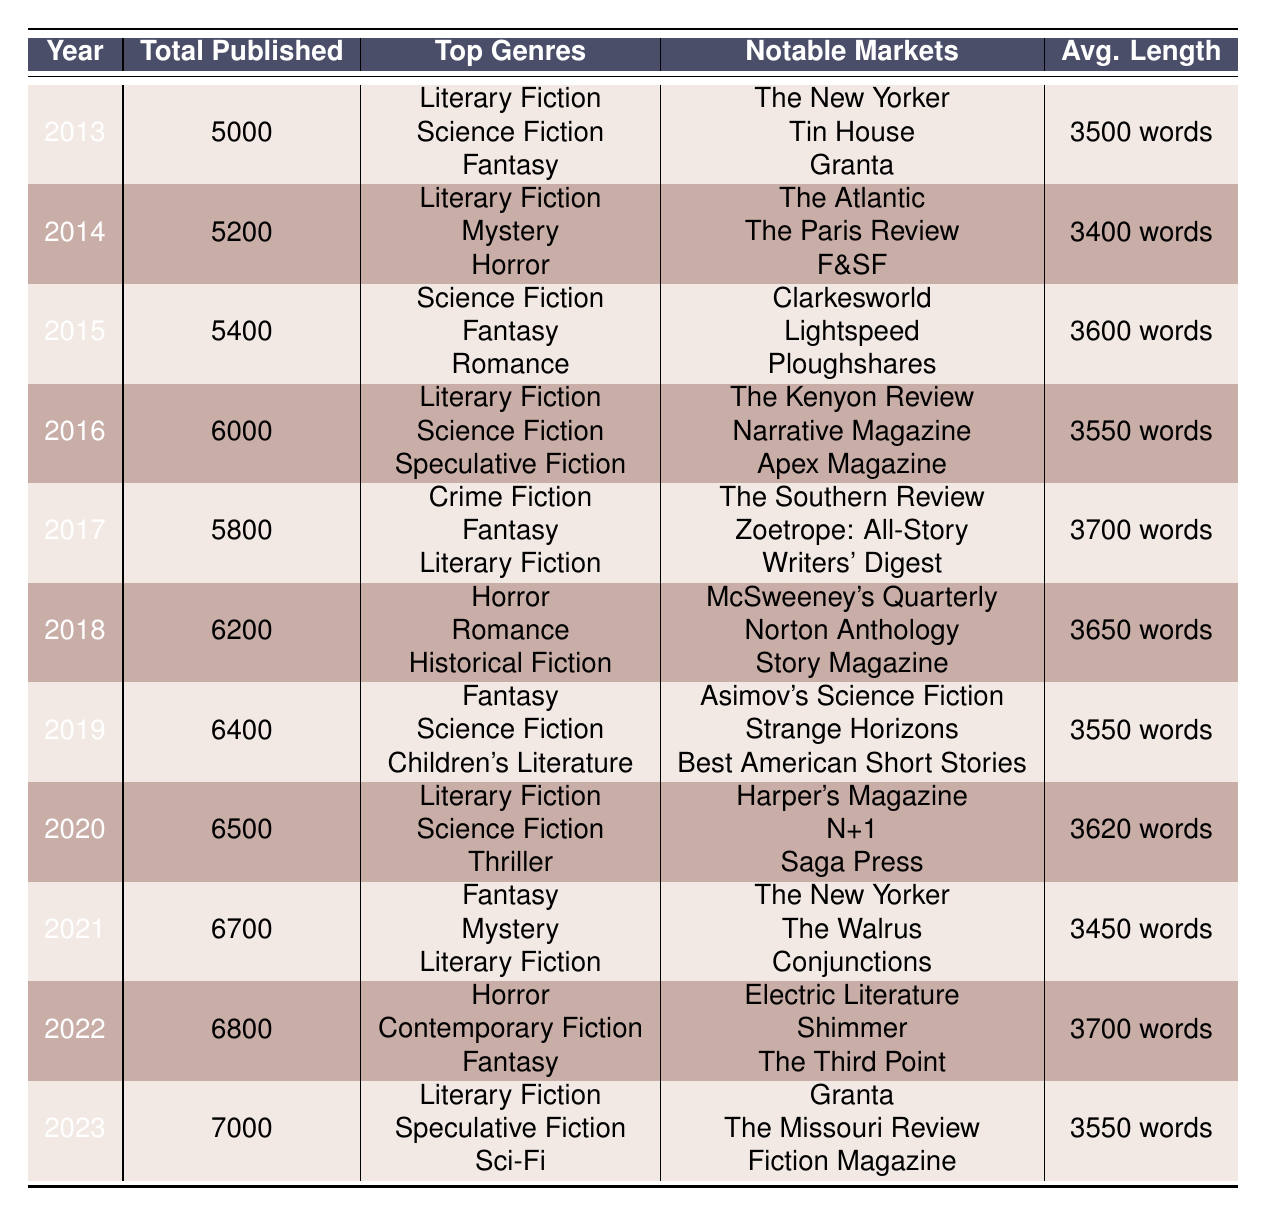What was the total number of short stories published in 2015? The table indicates that 5400 short stories were published in 2015, as listed under the "Total Published" column for that year.
Answer: 5400 Which genre was most commonly published in 2022? The top genres published in 2022 were Horror, Contemporary Fiction, and Fantasy. According to the table, Horror is listed first, indicating it was the most commonly published genre that year.
Answer: Horror What is the average story length for short stories published from 2013 to 2023? To find the average story length, we first list the lengths from each year: 3500, 3400, 3600, 3550, 3700, 3650, 3550, 3620, 3450, 3700, and 3550. There are 11 data points, and their total sum is 38870. So, the average length is 38870/11 ≈ 3533.64 words.
Answer: 3533.64 words Did more short stories get published in 2019 than in 2017? In 2019, there were 6400 short stories published, while in 2017, there were 5800. Since 6400 is greater than 5800, the statement is true.
Answer: Yes What genre alongside Literary Fiction was consistently one of the top three genres published between 2013 and 2023? Reviewing the top genres from the table, Science Fiction appears as a top genre in several years: 2013, 2015, 2016, and 2020. Given that it aligns with Literary Fiction in these years, it qualifies as a consistently published genre alongside it.
Answer: Science Fiction 